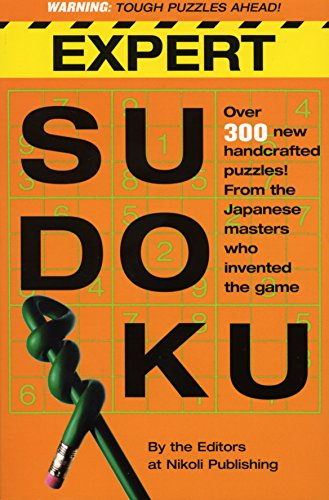Could you tell how many new puzzles are claimed to be in this book according to the cover? The cover of 'Expert Sudoku' states that there are 'Over 300 new handcrafted puzzles' inside, ready to challenge puzzle enthusiasts. 